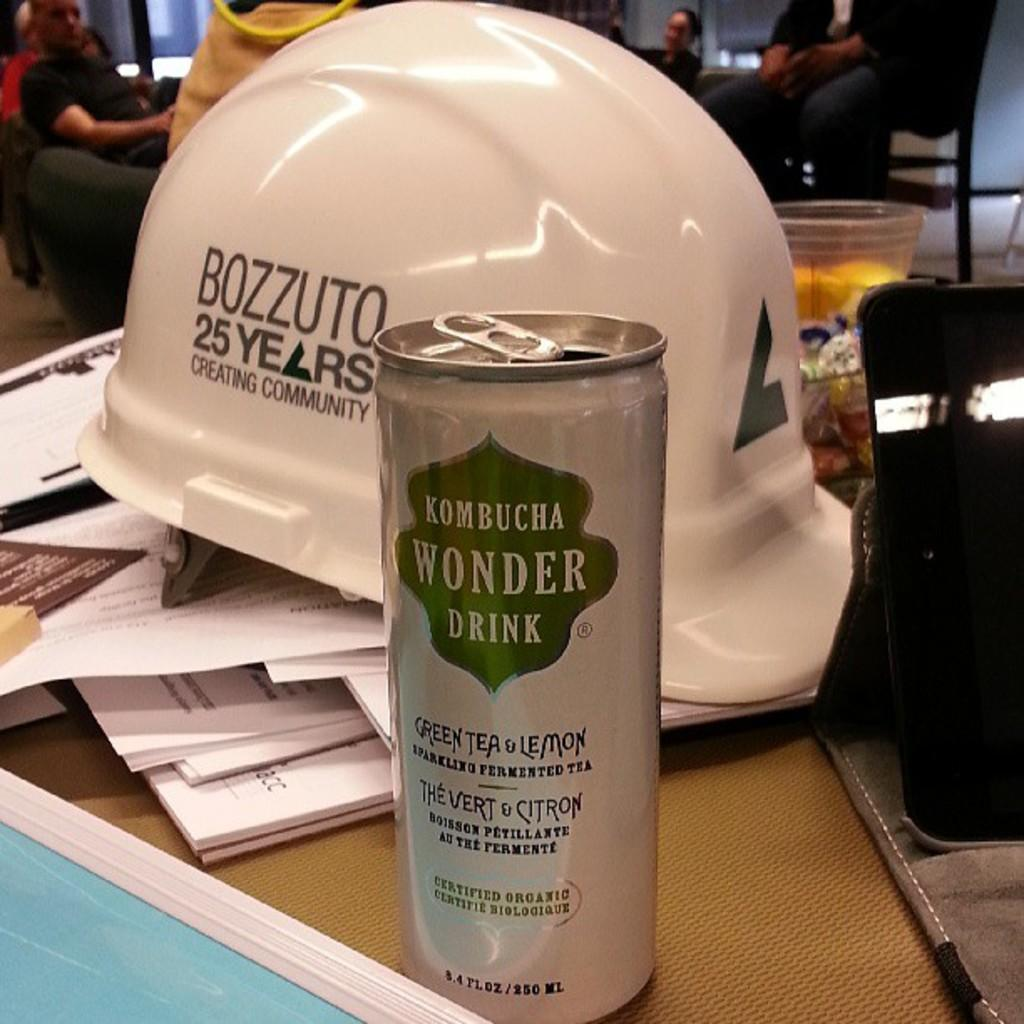What are the persons in the image wearing? The persons in the image are wearing clothes. What object is placed on papers in the image? There is a helmet on papers in the image. What type of container is at the bottom of the image? There is a tin at the bottom of the image. What electronic device is on the right side of the image? There is a tablet on the right side of the image. What song is being sung by the persons in the image? There is no indication in the image that the persons are singing a song, so it cannot be determined from the picture. --- Facts: 1. There is a person holding a book in the image. 2. The book has a blue cover. 3. The person is sitting on a chair. 4. There is a window in the background of the image. 5. The window has curtains. Absurd Topics: parrot, dance, ocean Conversation: What is the person in the image holding? The person in the image is holding a book. What color is the book's cover? The book has a blue cover. What type of furniture is the person sitting on? The person is sitting on a chair. What can be seen in the background of the image? There is a window in the background of the image. How are the curtains associated with the window? The window has curtains. Reasoning: Let's think step by step in order to produce the conversation. We start by identifying the main subject in the image, which is the person holding a book. Then, we describe the book's characteristics, such as its blue cover. Next, we mention the person's position and the type of furniture they are sitting on. Finally, we describe the background of the image, including the window and its curtains. Absurd Question/Answer: What type of parrot is sitting on the person's shoulder in the image? There is no parrot present in the image; the person is holding a book and sitting on a chair. --- Facts: 1. There is a person standing near a bicycle in the image. 2. The bicycle has two wheels. 3. The person is wearing a helmet. 4. There is a road in the background of the image. 5. The road has a yellow line. Absurd Topics: cake, rainbow, jump Conversation: What is the person standing near in the image? The person is standing near a bicycle in the image. How many wheels does the bicycle have? The bicycle has two wheels. What safety gear is the person wearing? The person is wearing a helmet. What can be seen in the background of the image? There is a road in the background of the image. Q: 